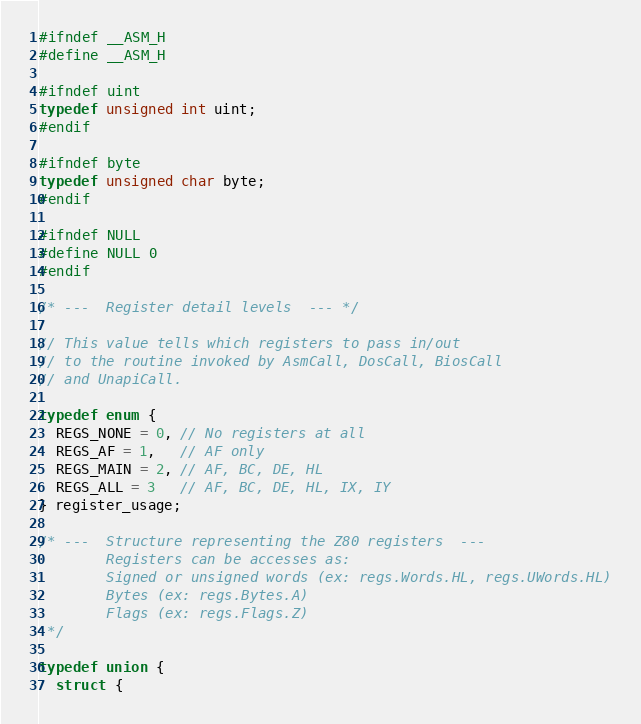<code> <loc_0><loc_0><loc_500><loc_500><_C_>#ifndef __ASM_H
#define __ASM_H

#ifndef uint
typedef unsigned int uint;
#endif

#ifndef byte
typedef unsigned char byte;
#endif

#ifndef NULL
#define NULL 0
#endif

/* ---  Register detail levels  --- */

// This value tells which registers to pass in/out
// to the routine invoked by AsmCall, DosCall, BiosCall
// and UnapiCall.

typedef enum {
  REGS_NONE = 0, // No registers at all
  REGS_AF = 1,   // AF only
  REGS_MAIN = 2, // AF, BC, DE, HL
  REGS_ALL = 3   // AF, BC, DE, HL, IX, IY
} register_usage;

/* ---  Structure representing the Z80 registers  ---
        Registers can be accesses as:
        Signed or unsigned words (ex: regs.Words.HL, regs.UWords.HL)
        Bytes (ex: regs.Bytes.A)
        Flags (ex: regs.Flags.Z)
 */

typedef union {
  struct {</code> 